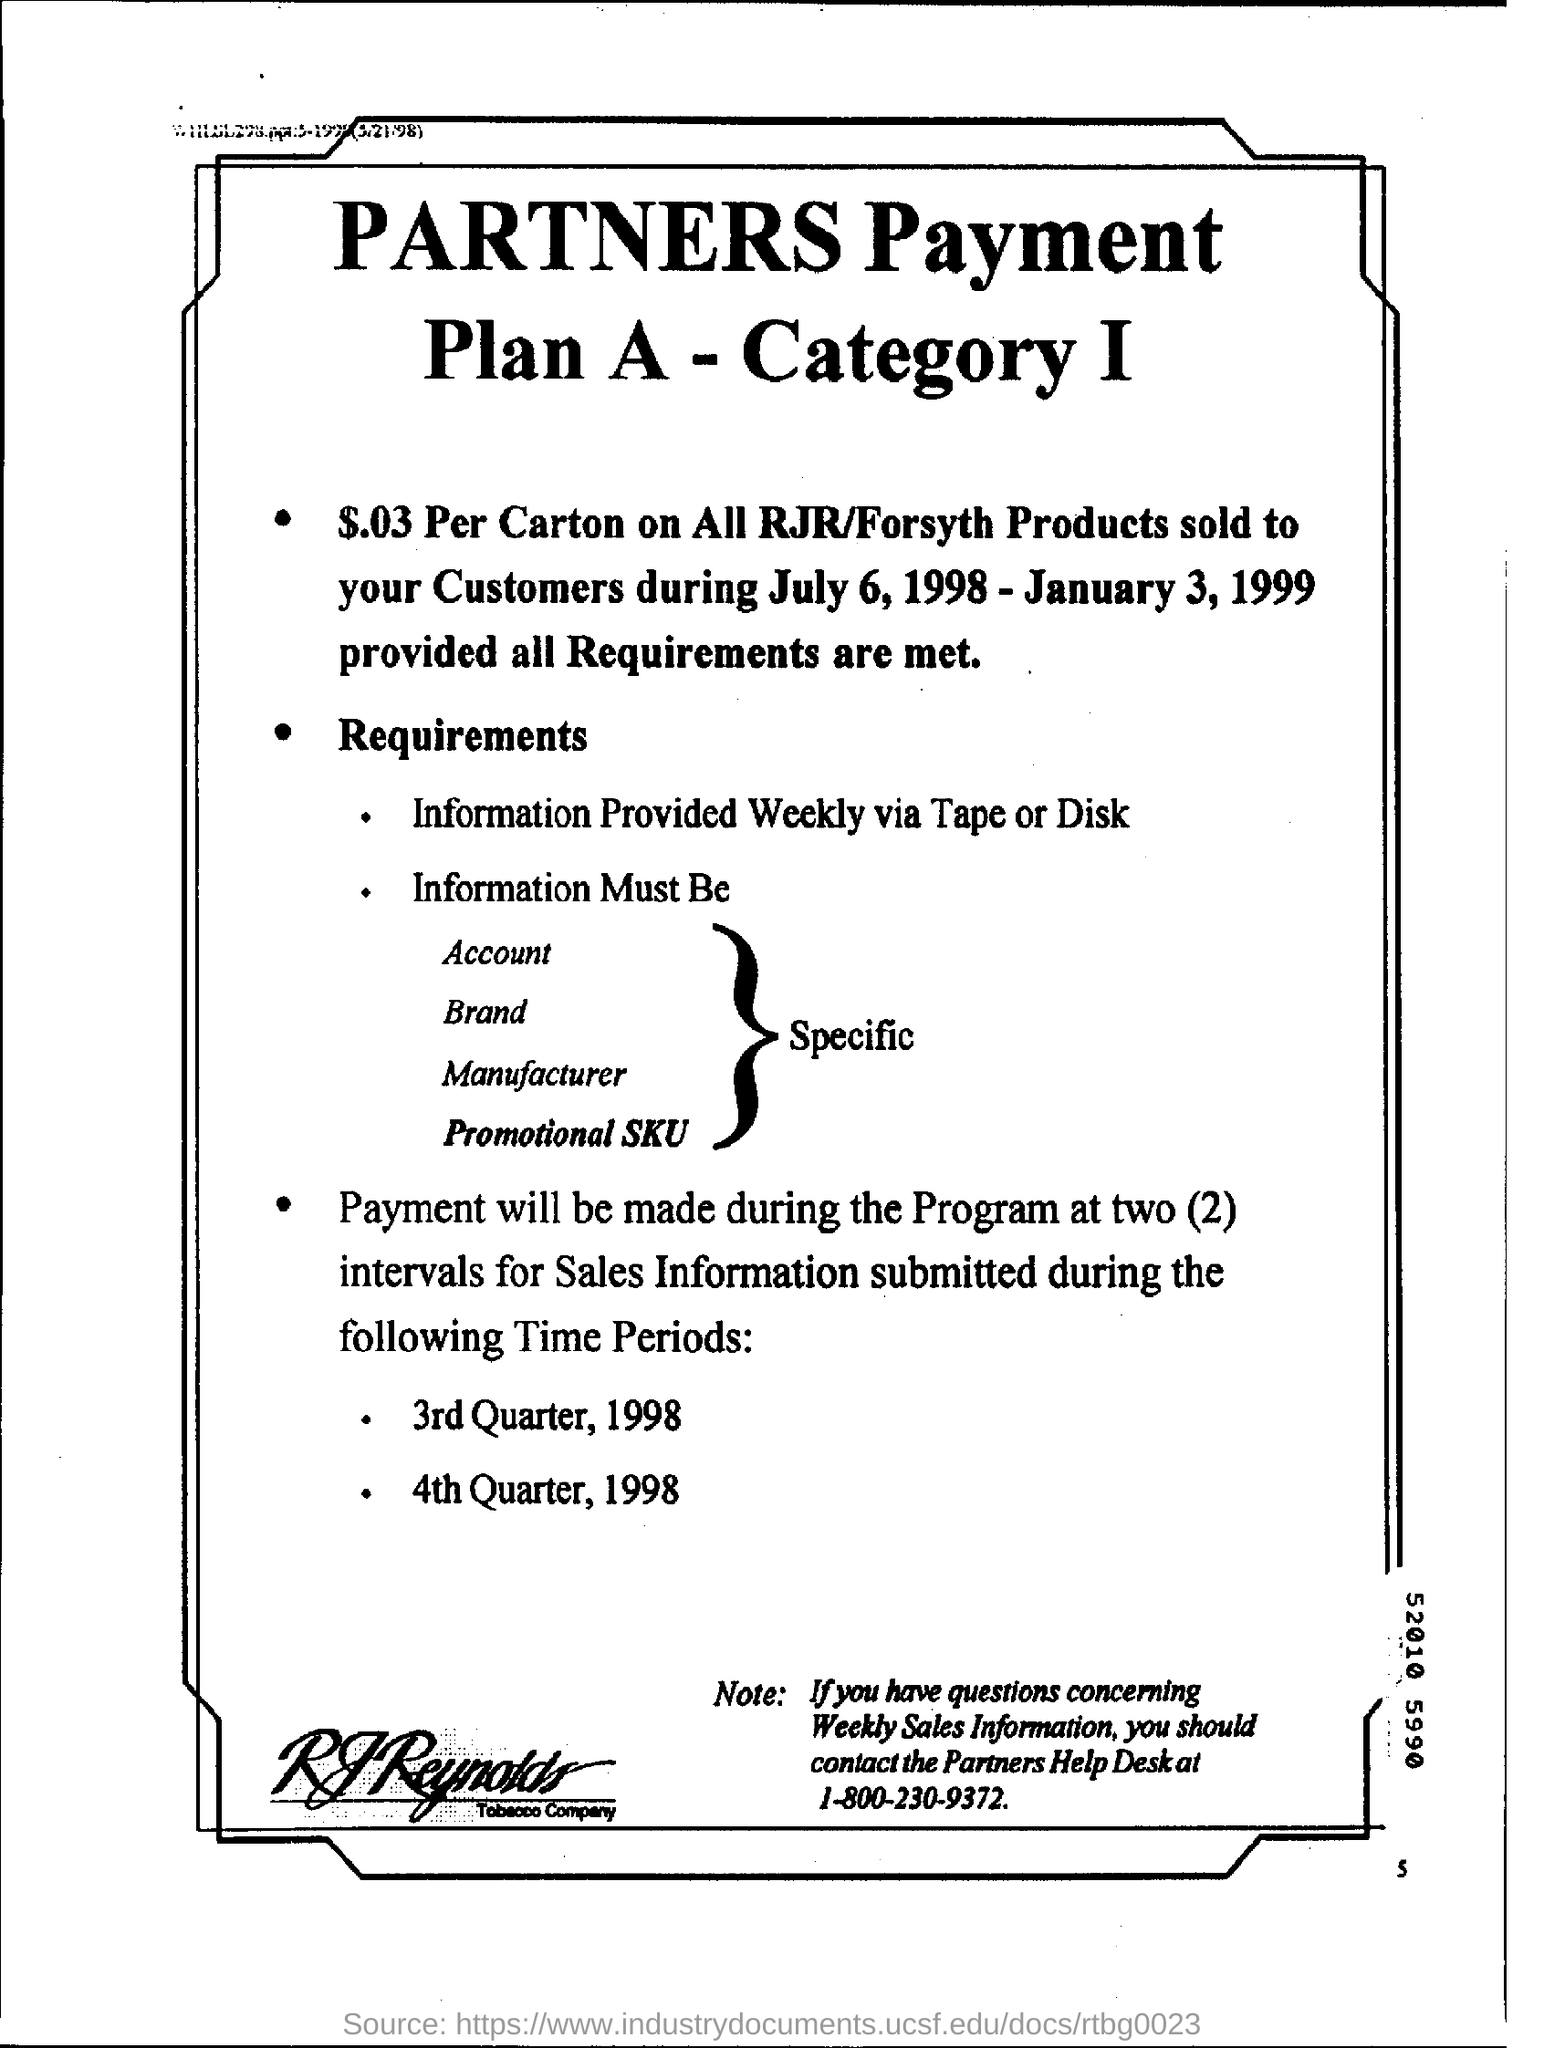How much dollar will be paid per carton ?
Provide a short and direct response. $.03. When will the payment be made?
Give a very brief answer. During the program at two (2) intervals. Payment will be made during the program at how many intervals?
Your answer should be very brief. (2) intervals. 